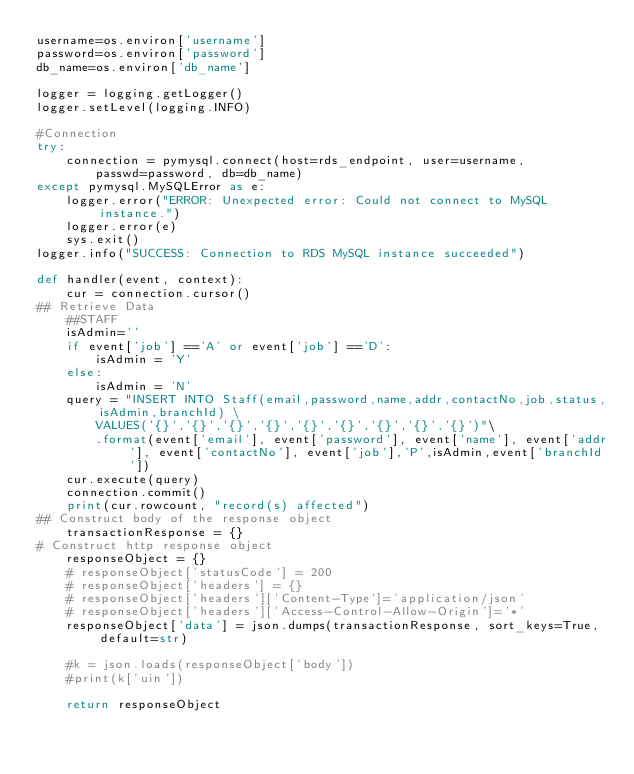<code> <loc_0><loc_0><loc_500><loc_500><_Python_>username=os.environ['username']
password=os.environ['password']
db_name=os.environ['db_name']

logger = logging.getLogger()
logger.setLevel(logging.INFO)

#Connection
try:
    connection = pymysql.connect(host=rds_endpoint, user=username,
        passwd=password, db=db_name)
except pymysql.MySQLError as e:
    logger.error("ERROR: Unexpected error: Could not connect to MySQL instance.")
    logger.error(e)
    sys.exit()
logger.info("SUCCESS: Connection to RDS MySQL instance succeeded")

def handler(event, context):
    cur = connection.cursor()  
## Retrieve Data
    ##STAFF
    isAdmin=''
    if event['job'] =='A' or event['job'] =='D':
        isAdmin = 'Y'
    else:
        isAdmin = 'N'
    query = "INSERT INTO Staff(email,password,name,addr,contactNo,job,status,isAdmin,branchId) \
        VALUES('{}','{}','{}','{}','{}','{}','{}','{}','{}')"\
        .format(event['email'], event['password'], event['name'], event['addr'], event['contactNo'], event['job'],'P',isAdmin,event['branchId'])
    cur.execute(query)
    connection.commit()
    print(cur.rowcount, "record(s) affected")
## Construct body of the response object
    transactionResponse = {}
# Construct http response object
    responseObject = {}
    # responseObject['statusCode'] = 200
    # responseObject['headers'] = {}
    # responseObject['headers']['Content-Type']='application/json'
    # responseObject['headers']['Access-Control-Allow-Origin']='*'
    responseObject['data'] = json.dumps(transactionResponse, sort_keys=True,default=str)
    
    #k = json.loads(responseObject['body'])
    #print(k['uin'])

    return responseObject</code> 